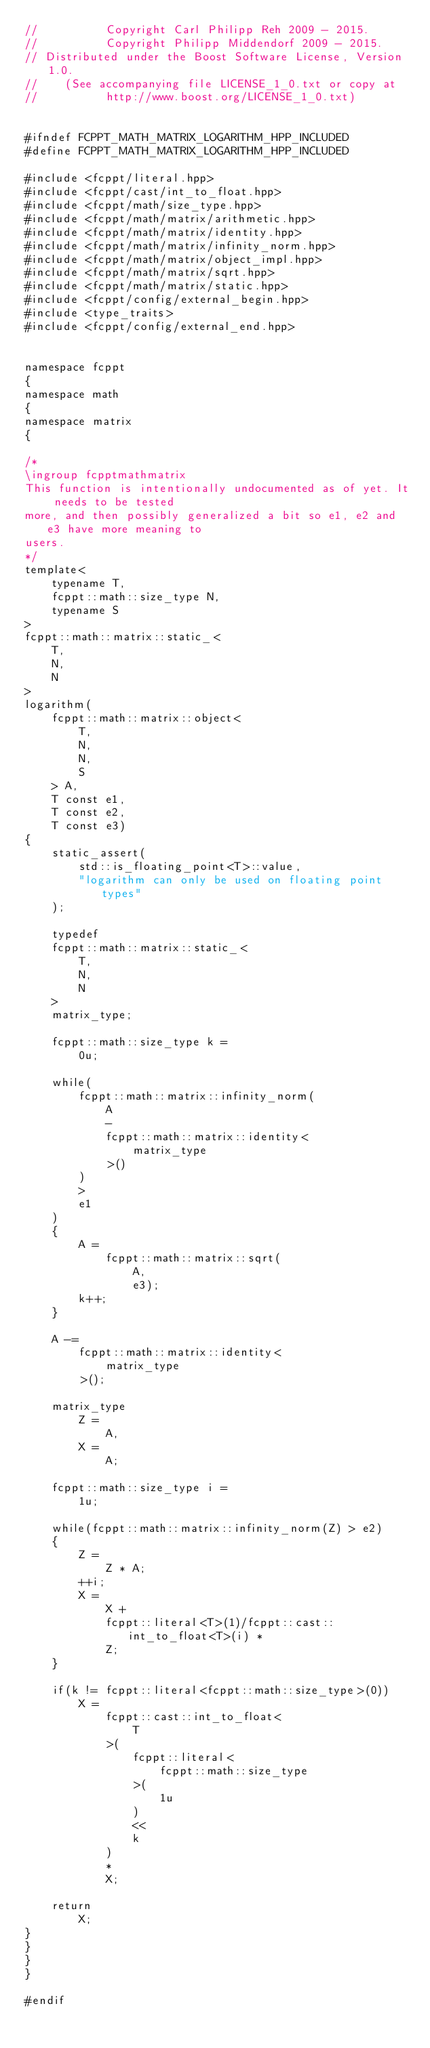<code> <loc_0><loc_0><loc_500><loc_500><_C++_>//          Copyright Carl Philipp Reh 2009 - 2015.
//          Copyright Philipp Middendorf 2009 - 2015.
// Distributed under the Boost Software License, Version 1.0.
//    (See accompanying file LICENSE_1_0.txt or copy at
//          http://www.boost.org/LICENSE_1_0.txt)


#ifndef FCPPT_MATH_MATRIX_LOGARITHM_HPP_INCLUDED
#define FCPPT_MATH_MATRIX_LOGARITHM_HPP_INCLUDED

#include <fcppt/literal.hpp>
#include <fcppt/cast/int_to_float.hpp>
#include <fcppt/math/size_type.hpp>
#include <fcppt/math/matrix/arithmetic.hpp>
#include <fcppt/math/matrix/identity.hpp>
#include <fcppt/math/matrix/infinity_norm.hpp>
#include <fcppt/math/matrix/object_impl.hpp>
#include <fcppt/math/matrix/sqrt.hpp>
#include <fcppt/math/matrix/static.hpp>
#include <fcppt/config/external_begin.hpp>
#include <type_traits>
#include <fcppt/config/external_end.hpp>


namespace fcppt
{
namespace math
{
namespace matrix
{

/*
\ingroup fcpptmathmatrix
This function is intentionally undocumented as of yet. It needs to be tested
more, and then possibly generalized a bit so e1, e2 and e3 have more meaning to
users.
*/
template<
	typename T,
	fcppt::math::size_type N,
	typename S
>
fcppt::math::matrix::static_<
	T,
	N,
	N
>
logarithm(
	fcppt::math::matrix::object<
		T,
		N,
		N,
		S
	> A,
	T const e1,
	T const e2,
	T const e3)
{
	static_assert(
		std::is_floating_point<T>::value,
		"logarithm can only be used on floating point types"
	);

	typedef
	fcppt::math::matrix::static_<
		T,
		N,
		N
	>
	matrix_type;

	fcppt::math::size_type k =
		0u;

	while(
		fcppt::math::matrix::infinity_norm(
			A
			-
			fcppt::math::matrix::identity<
				matrix_type
			>()
		)
		>
		e1
	)
	{
		A =
			fcppt::math::matrix::sqrt(
				A,
				e3);
		k++;
	}

	A -=
		fcppt::math::matrix::identity<
			matrix_type
		>();

	matrix_type
		Z =
			A,
		X =
			A;

	fcppt::math::size_type i =
		1u;

	while(fcppt::math::matrix::infinity_norm(Z) > e2)
	{
		Z =
			Z * A;
		++i;
		X =
			X +
			fcppt::literal<T>(1)/fcppt::cast::int_to_float<T>(i) *
			Z;
	}

	if(k != fcppt::literal<fcppt::math::size_type>(0))
		X =
			fcppt::cast::int_to_float<
				T
			>(
				fcppt::literal<
					fcppt::math::size_type
				>(
					1u
				)
				<<
				k
			)
			*
			X;

	return
		X;
}
}
}
}

#endif
</code> 